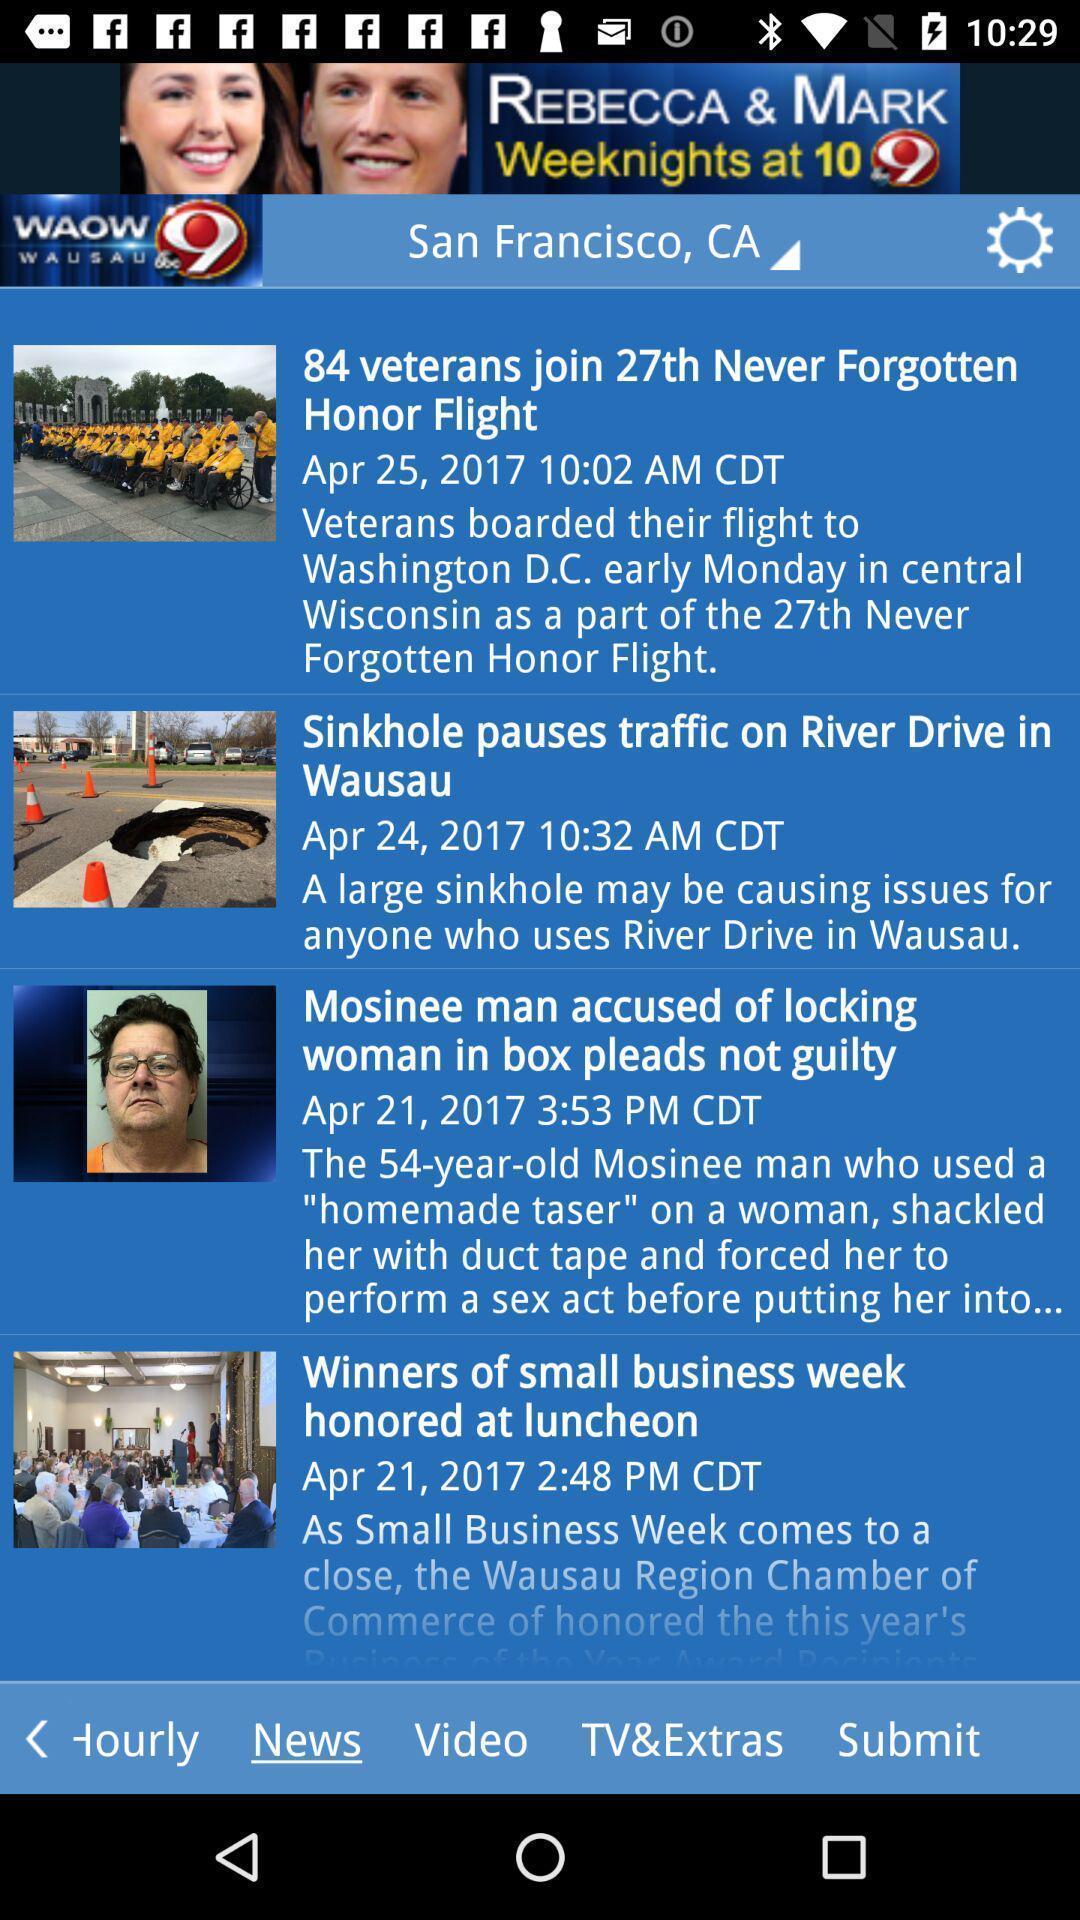Explain what's happening in this screen capture. Screen page of a news updates. 